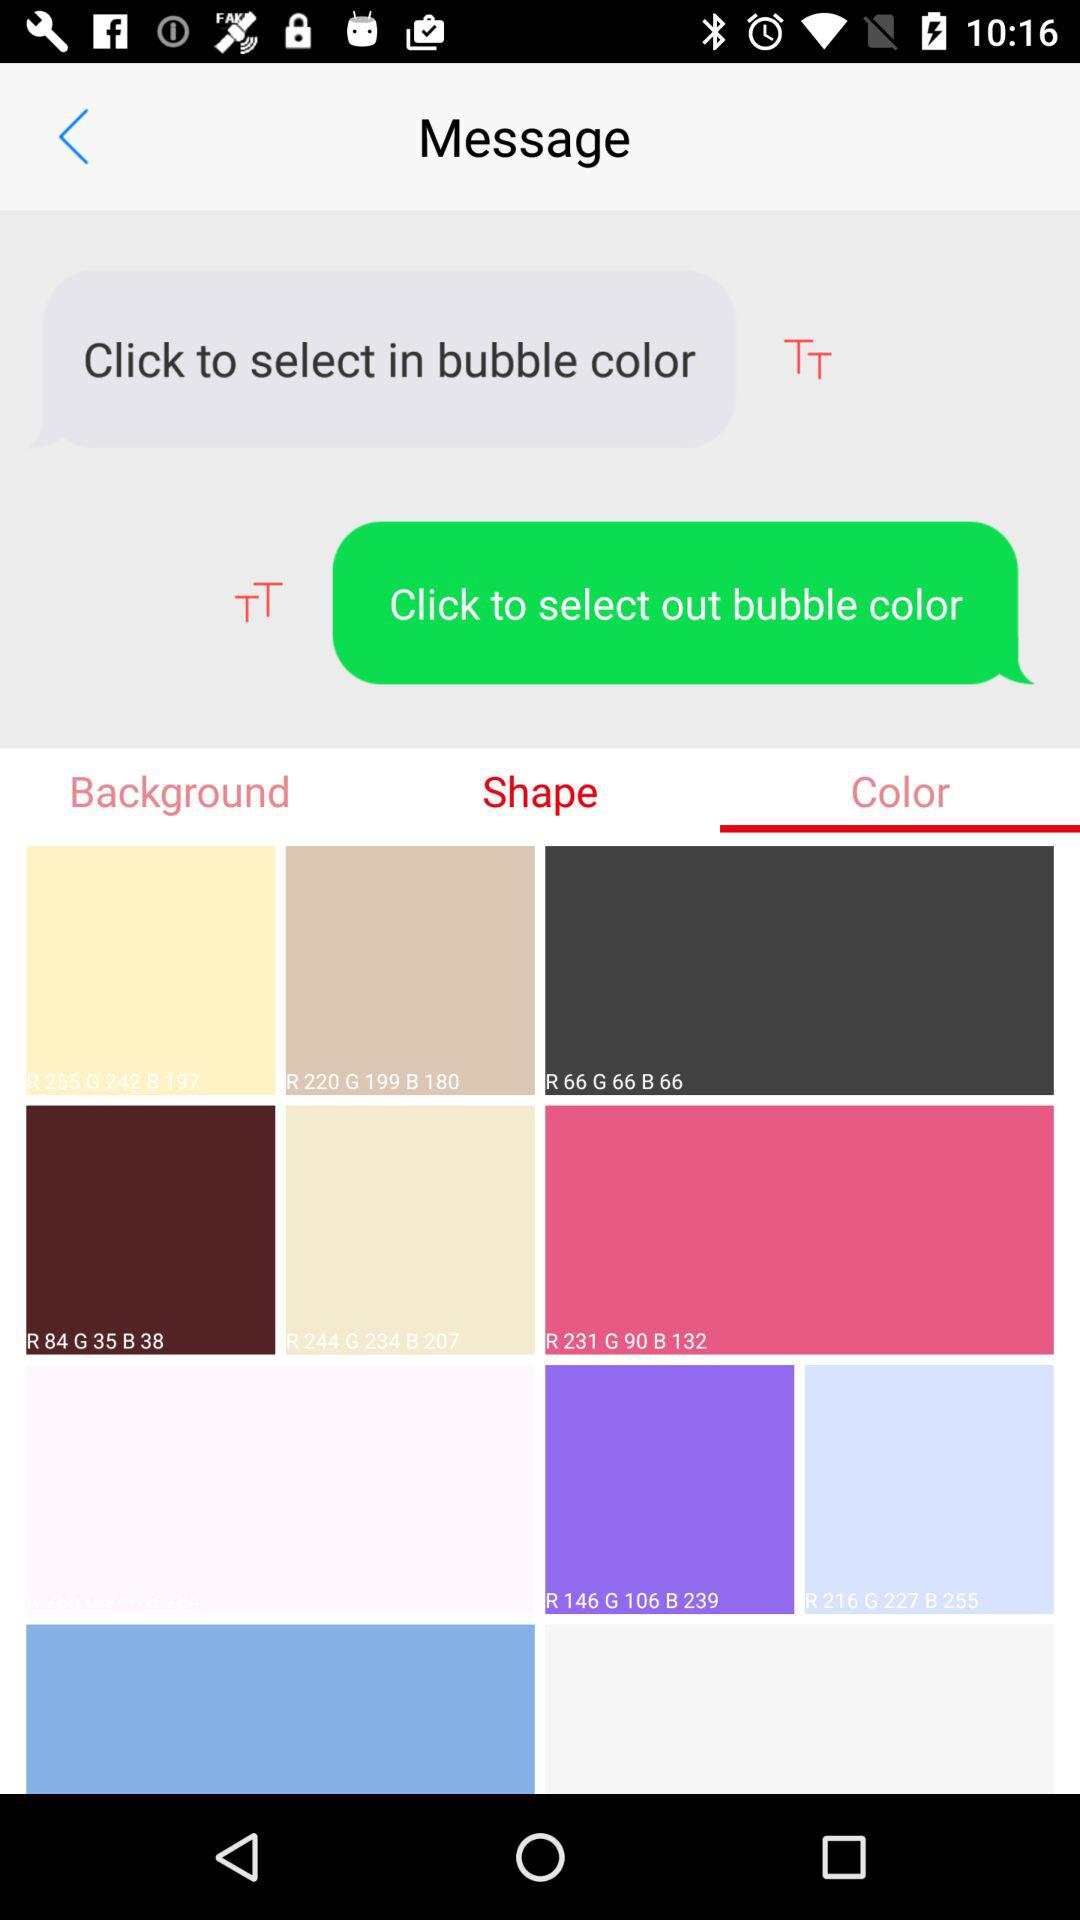Which tab is selected? The selected tab is "Color". 